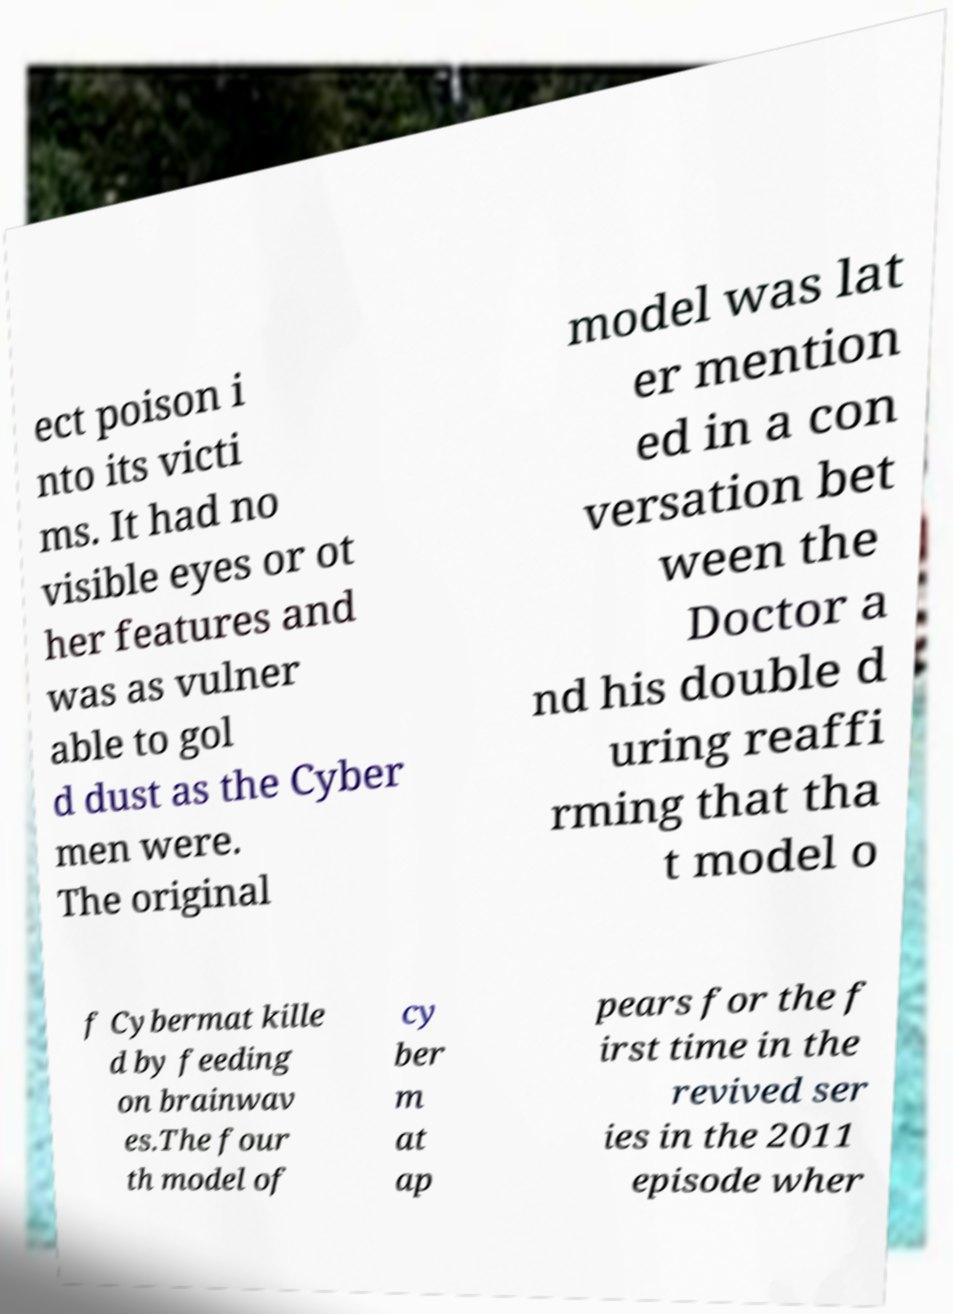There's text embedded in this image that I need extracted. Can you transcribe it verbatim? ect poison i nto its victi ms. It had no visible eyes or ot her features and was as vulner able to gol d dust as the Cyber men were. The original model was lat er mention ed in a con versation bet ween the Doctor a nd his double d uring reaffi rming that tha t model o f Cybermat kille d by feeding on brainwav es.The four th model of cy ber m at ap pears for the f irst time in the revived ser ies in the 2011 episode wher 